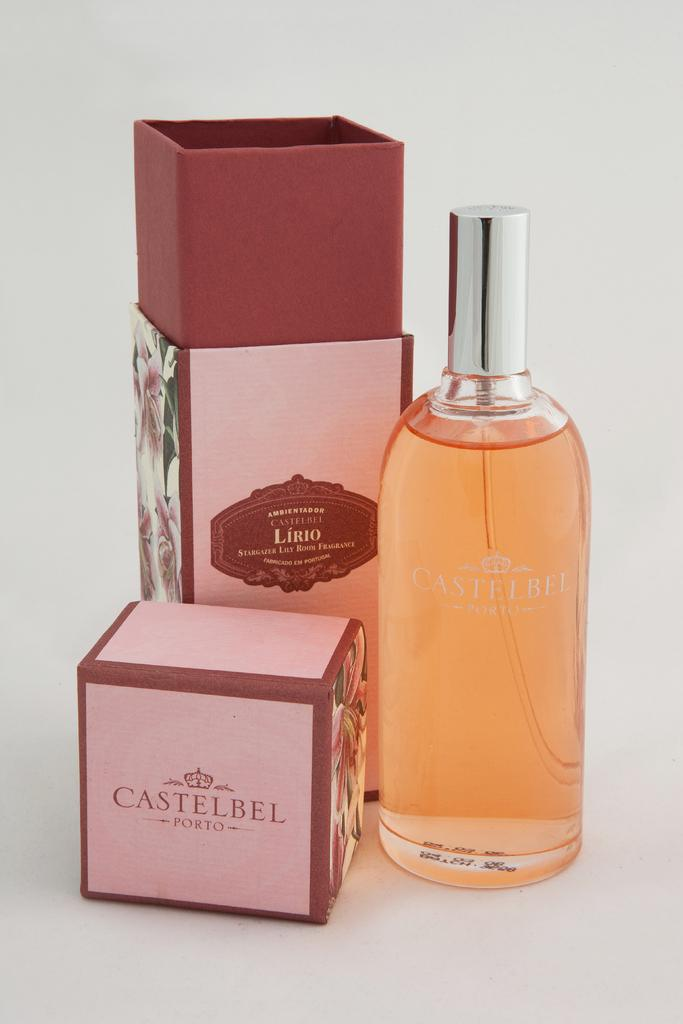Provide a one-sentence caption for the provided image. Boxes and bottle that say castelbel Porto on them. 